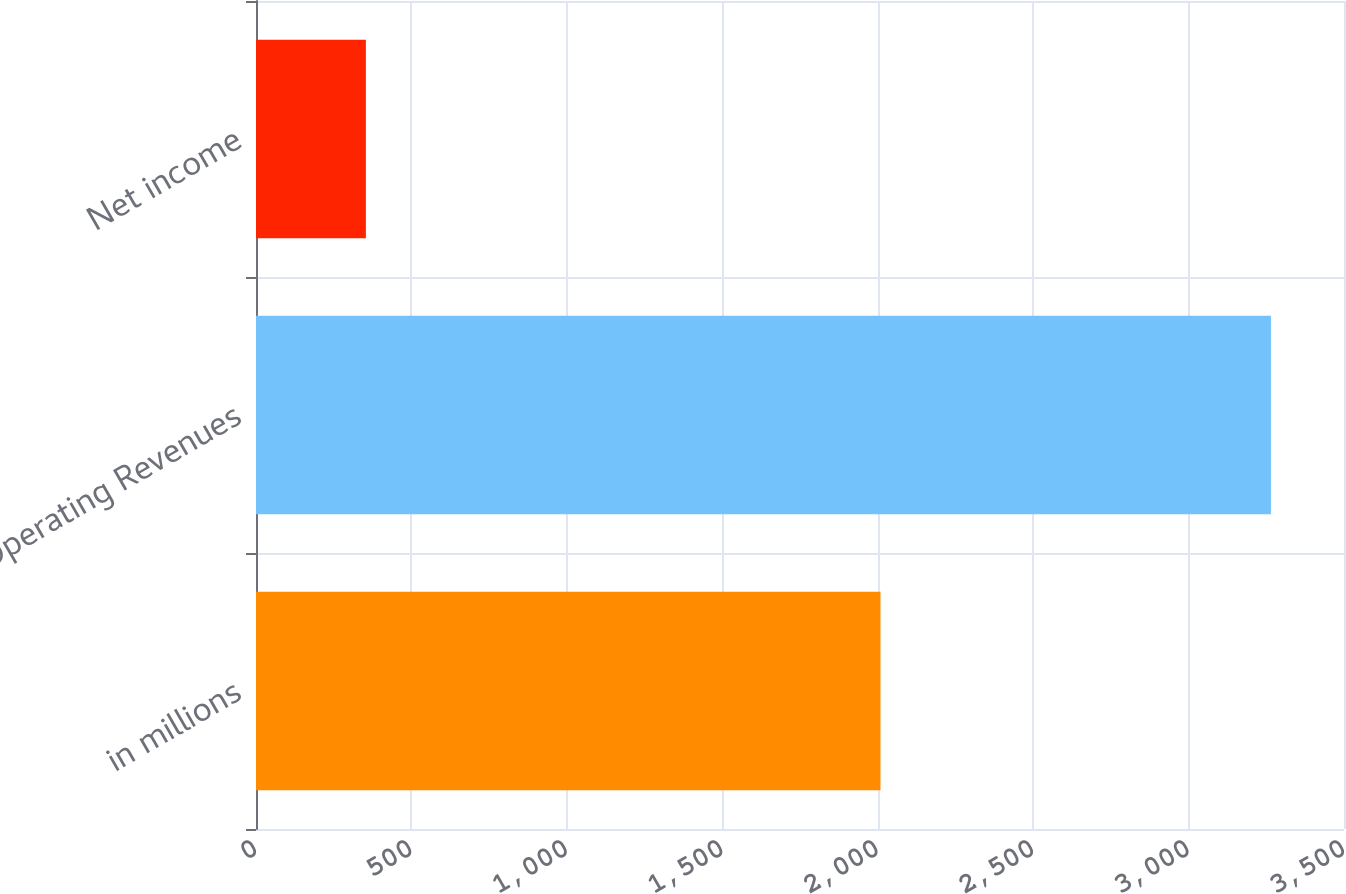Convert chart. <chart><loc_0><loc_0><loc_500><loc_500><bar_chart><fcel>in millions<fcel>Operating Revenues<fcel>Net income<nl><fcel>2009<fcel>3264.9<fcel>353.5<nl></chart> 